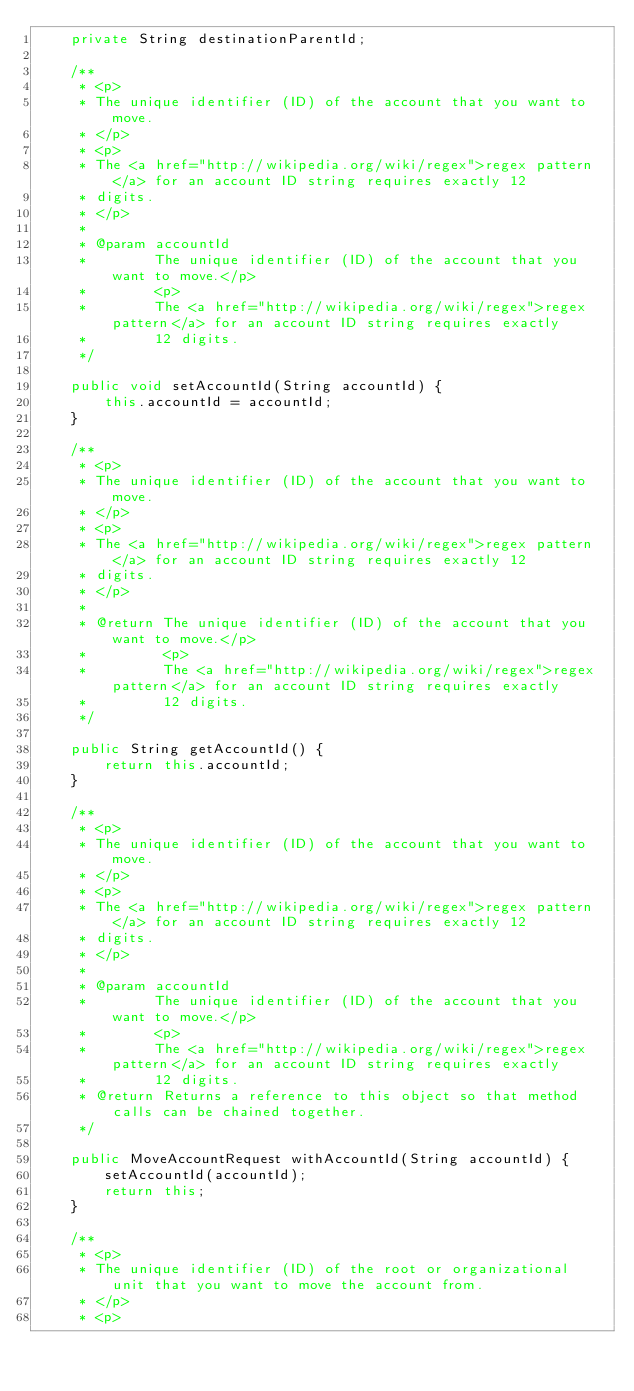Convert code to text. <code><loc_0><loc_0><loc_500><loc_500><_Java_>    private String destinationParentId;

    /**
     * <p>
     * The unique identifier (ID) of the account that you want to move.
     * </p>
     * <p>
     * The <a href="http://wikipedia.org/wiki/regex">regex pattern</a> for an account ID string requires exactly 12
     * digits.
     * </p>
     * 
     * @param accountId
     *        The unique identifier (ID) of the account that you want to move.</p>
     *        <p>
     *        The <a href="http://wikipedia.org/wiki/regex">regex pattern</a> for an account ID string requires exactly
     *        12 digits.
     */

    public void setAccountId(String accountId) {
        this.accountId = accountId;
    }

    /**
     * <p>
     * The unique identifier (ID) of the account that you want to move.
     * </p>
     * <p>
     * The <a href="http://wikipedia.org/wiki/regex">regex pattern</a> for an account ID string requires exactly 12
     * digits.
     * </p>
     * 
     * @return The unique identifier (ID) of the account that you want to move.</p>
     *         <p>
     *         The <a href="http://wikipedia.org/wiki/regex">regex pattern</a> for an account ID string requires exactly
     *         12 digits.
     */

    public String getAccountId() {
        return this.accountId;
    }

    /**
     * <p>
     * The unique identifier (ID) of the account that you want to move.
     * </p>
     * <p>
     * The <a href="http://wikipedia.org/wiki/regex">regex pattern</a> for an account ID string requires exactly 12
     * digits.
     * </p>
     * 
     * @param accountId
     *        The unique identifier (ID) of the account that you want to move.</p>
     *        <p>
     *        The <a href="http://wikipedia.org/wiki/regex">regex pattern</a> for an account ID string requires exactly
     *        12 digits.
     * @return Returns a reference to this object so that method calls can be chained together.
     */

    public MoveAccountRequest withAccountId(String accountId) {
        setAccountId(accountId);
        return this;
    }

    /**
     * <p>
     * The unique identifier (ID) of the root or organizational unit that you want to move the account from.
     * </p>
     * <p></code> 